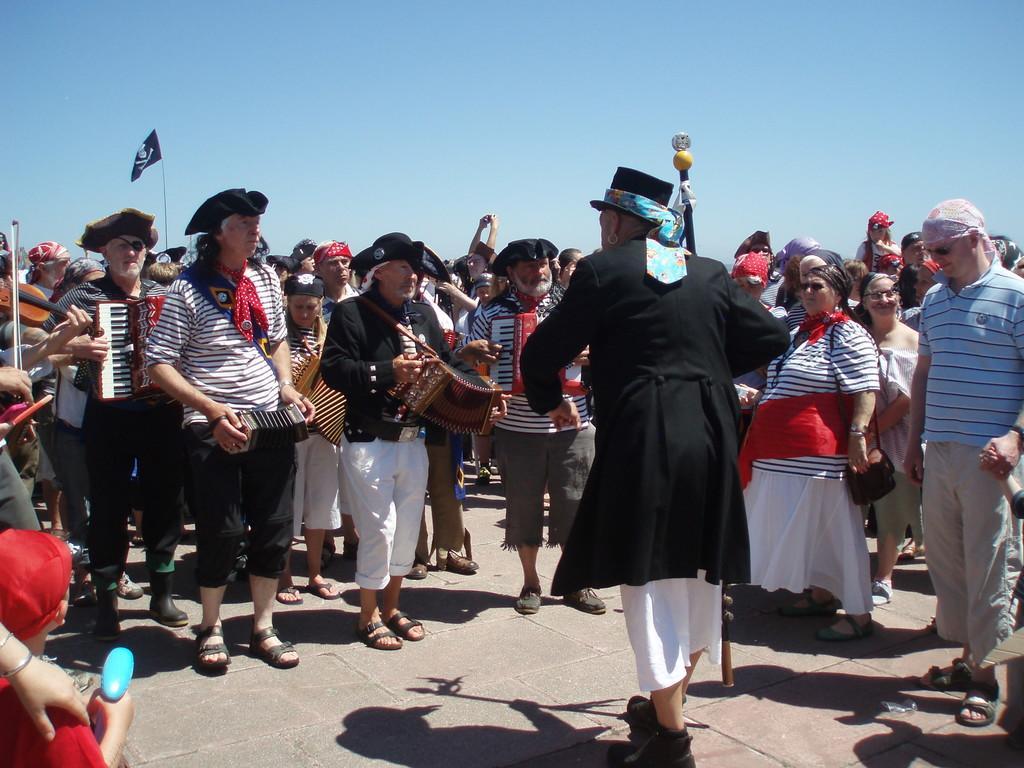Could you give a brief overview of what you see in this image? This picture shows a group of people performing musical instruments and few people are watching them standing 